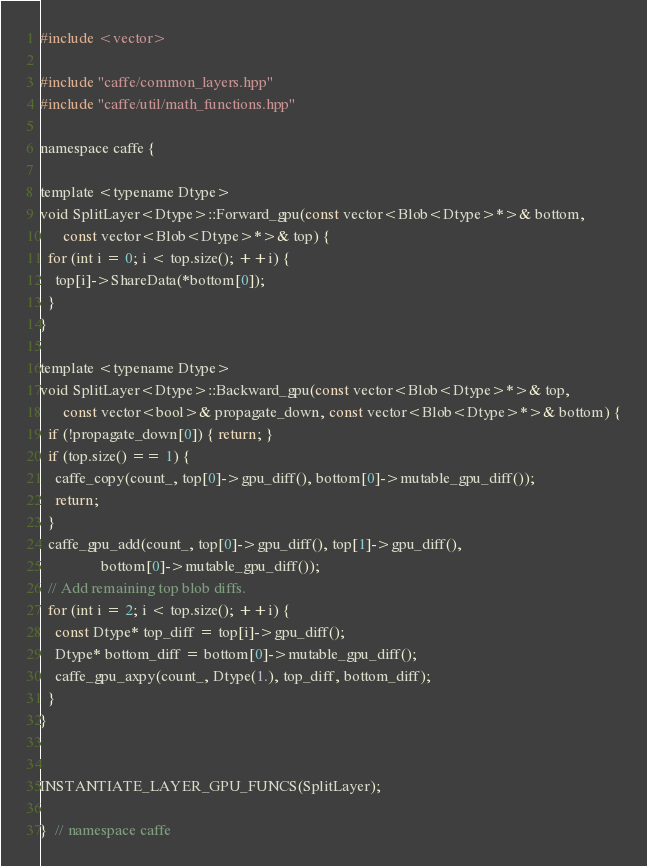<code> <loc_0><loc_0><loc_500><loc_500><_Cuda_>#include <vector>

#include "caffe/common_layers.hpp"
#include "caffe/util/math_functions.hpp"

namespace caffe {

template <typename Dtype>
void SplitLayer<Dtype>::Forward_gpu(const vector<Blob<Dtype>*>& bottom,
      const vector<Blob<Dtype>*>& top) {
  for (int i = 0; i < top.size(); ++i) {
    top[i]->ShareData(*bottom[0]);
  }
}

template <typename Dtype>
void SplitLayer<Dtype>::Backward_gpu(const vector<Blob<Dtype>*>& top,
      const vector<bool>& propagate_down, const vector<Blob<Dtype>*>& bottom) {
  if (!propagate_down[0]) { return; }
  if (top.size() == 1) {
    caffe_copy(count_, top[0]->gpu_diff(), bottom[0]->mutable_gpu_diff());
    return;
  }
  caffe_gpu_add(count_, top[0]->gpu_diff(), top[1]->gpu_diff(),
                bottom[0]->mutable_gpu_diff());
  // Add remaining top blob diffs.
  for (int i = 2; i < top.size(); ++i) {
    const Dtype* top_diff = top[i]->gpu_diff();
    Dtype* bottom_diff = bottom[0]->mutable_gpu_diff();
    caffe_gpu_axpy(count_, Dtype(1.), top_diff, bottom_diff);
  }
}


INSTANTIATE_LAYER_GPU_FUNCS(SplitLayer);

}  // namespace caffe
</code> 